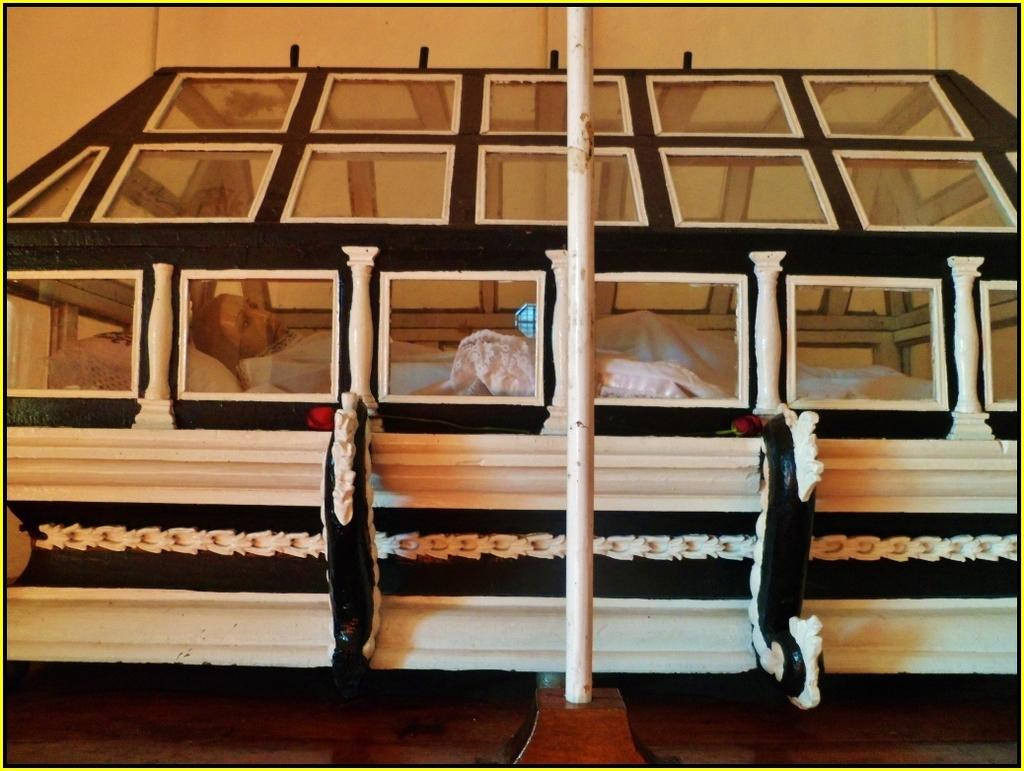What is the main structure in the image? There is a pole in the image. What is the color of the object that contains the mannequin? The object is white. What is inside the white object? A mannequin is present in the white object. What is the mannequin wearing? The mannequin is wearing a white dress. What type of letters can be seen inside the vase in the image? There is no vase present in the image, and therefore no letters can be seen inside it. 